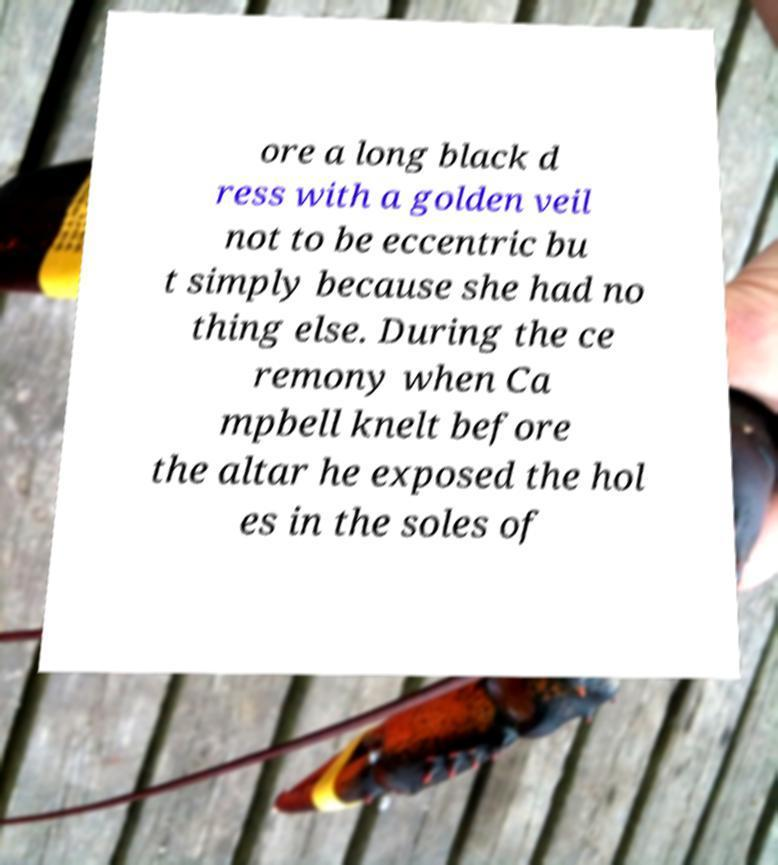Could you extract and type out the text from this image? ore a long black d ress with a golden veil not to be eccentric bu t simply because she had no thing else. During the ce remony when Ca mpbell knelt before the altar he exposed the hol es in the soles of 